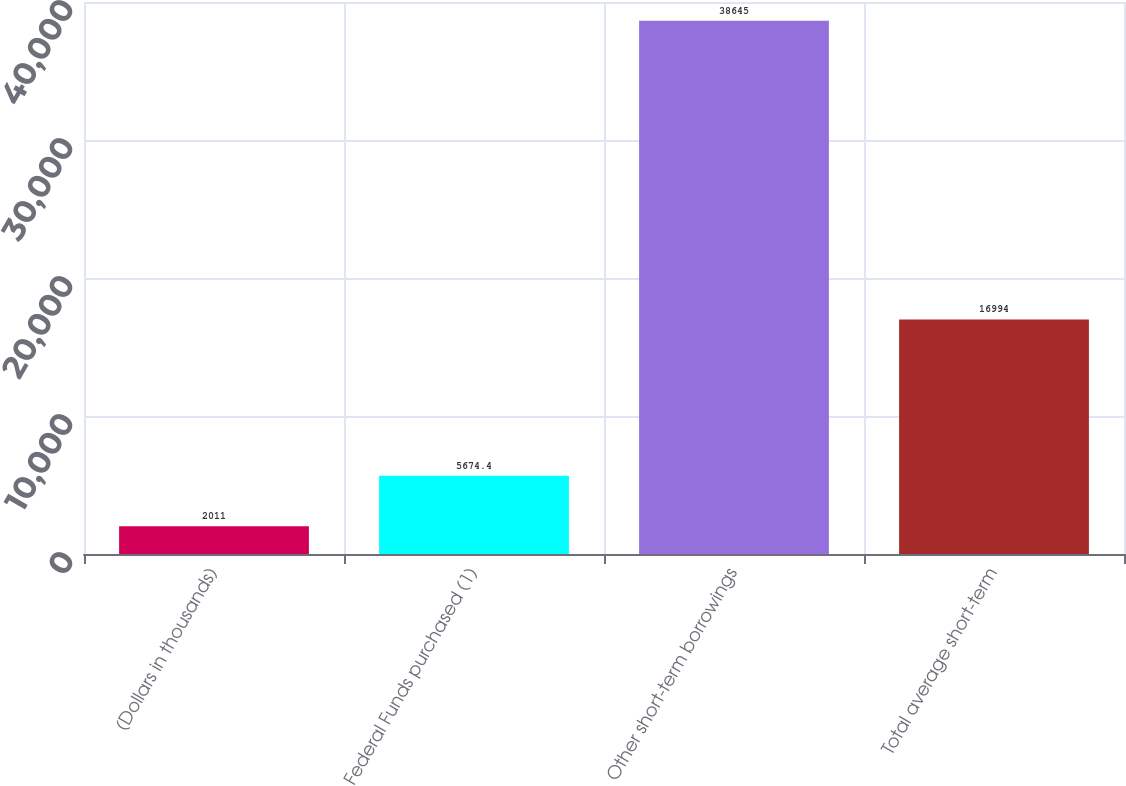Convert chart to OTSL. <chart><loc_0><loc_0><loc_500><loc_500><bar_chart><fcel>(Dollars in thousands)<fcel>Federal Funds purchased (1)<fcel>Other short-term borrowings<fcel>Total average short-term<nl><fcel>2011<fcel>5674.4<fcel>38645<fcel>16994<nl></chart> 